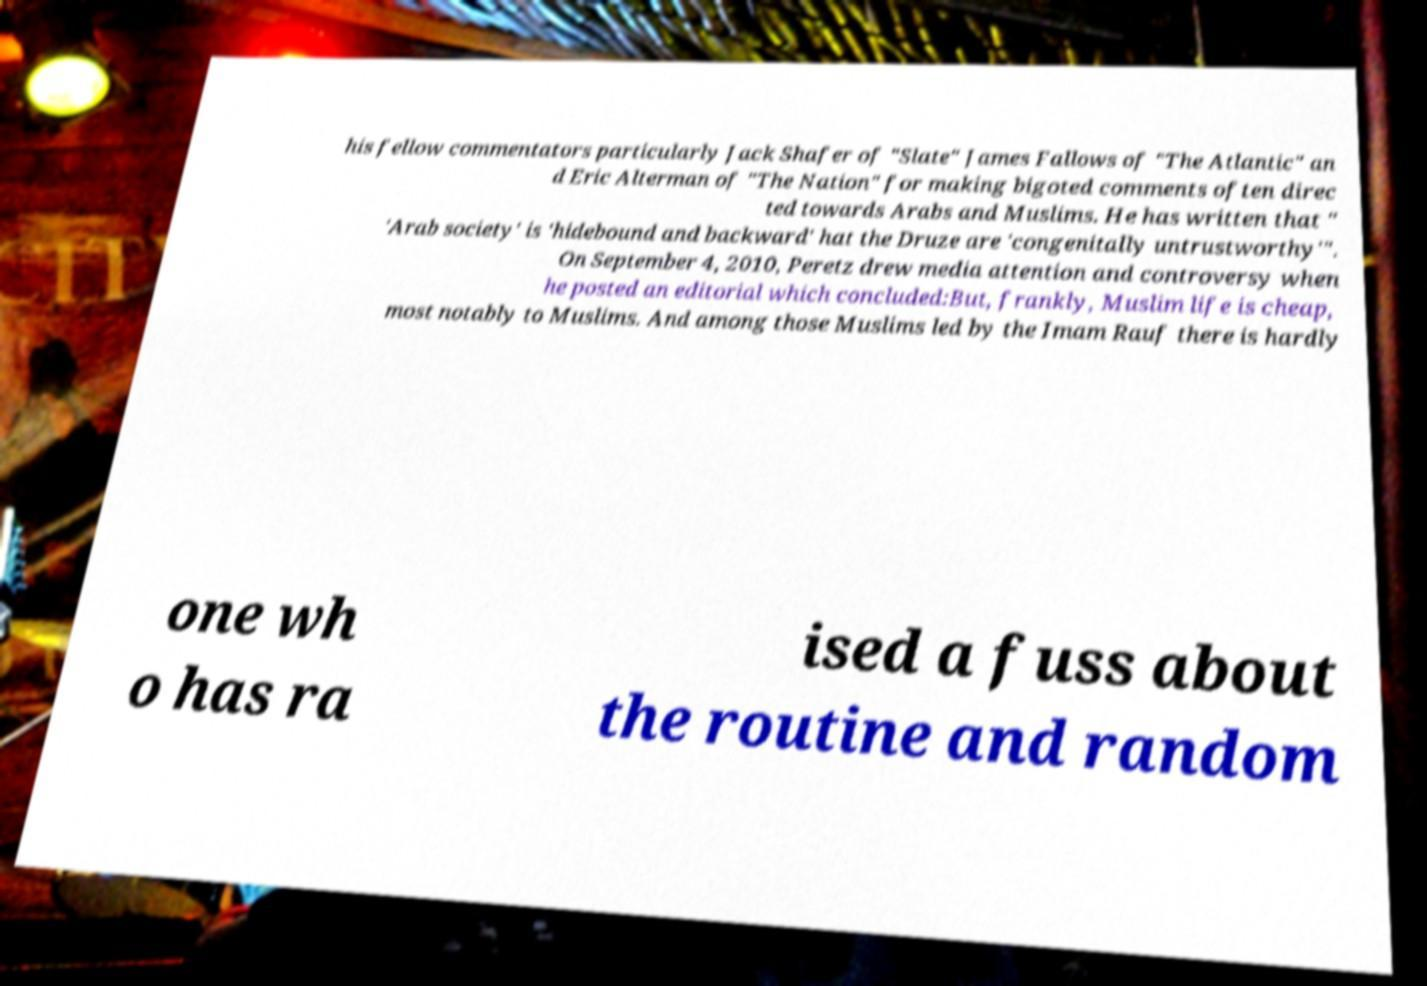What messages or text are displayed in this image? I need them in a readable, typed format. his fellow commentators particularly Jack Shafer of "Slate" James Fallows of "The Atlantic" an d Eric Alterman of "The Nation" for making bigoted comments often direc ted towards Arabs and Muslims. He has written that " 'Arab society' is 'hidebound and backward' hat the Druze are 'congenitally untrustworthy'". On September 4, 2010, Peretz drew media attention and controversy when he posted an editorial which concluded:But, frankly, Muslim life is cheap, most notably to Muslims. And among those Muslims led by the Imam Rauf there is hardly one wh o has ra ised a fuss about the routine and random 